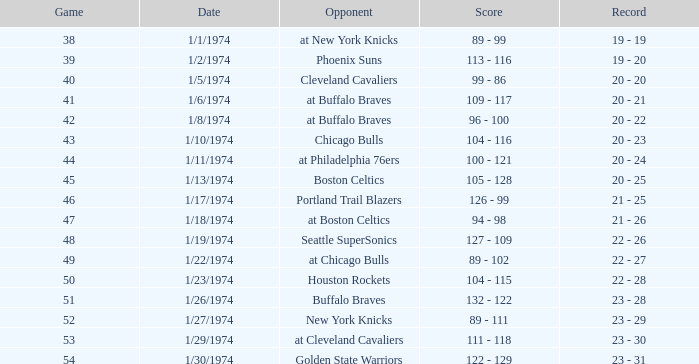Which competitor took part on 1/13/1974? Boston Celtics. 